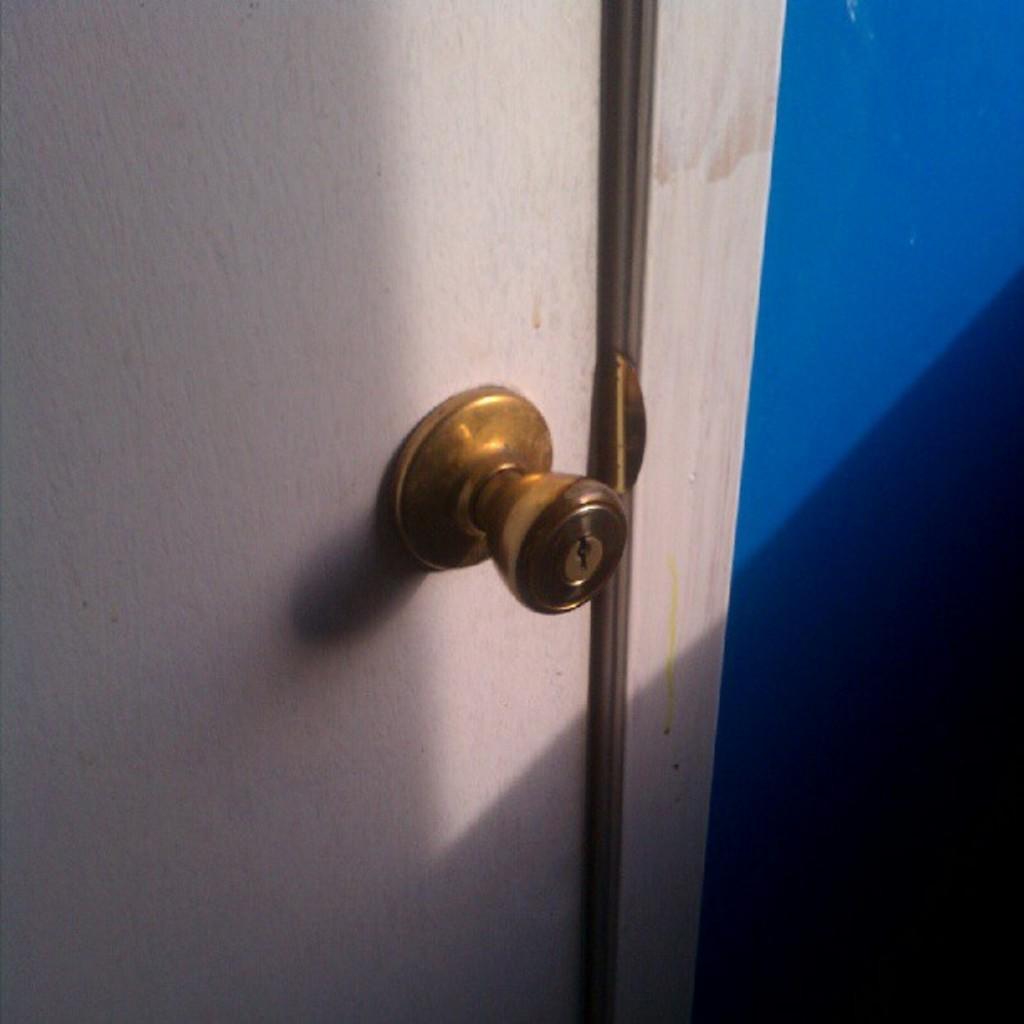Please provide a concise description of this image. In this picture we observe a white door where there is a metal knob on it. 